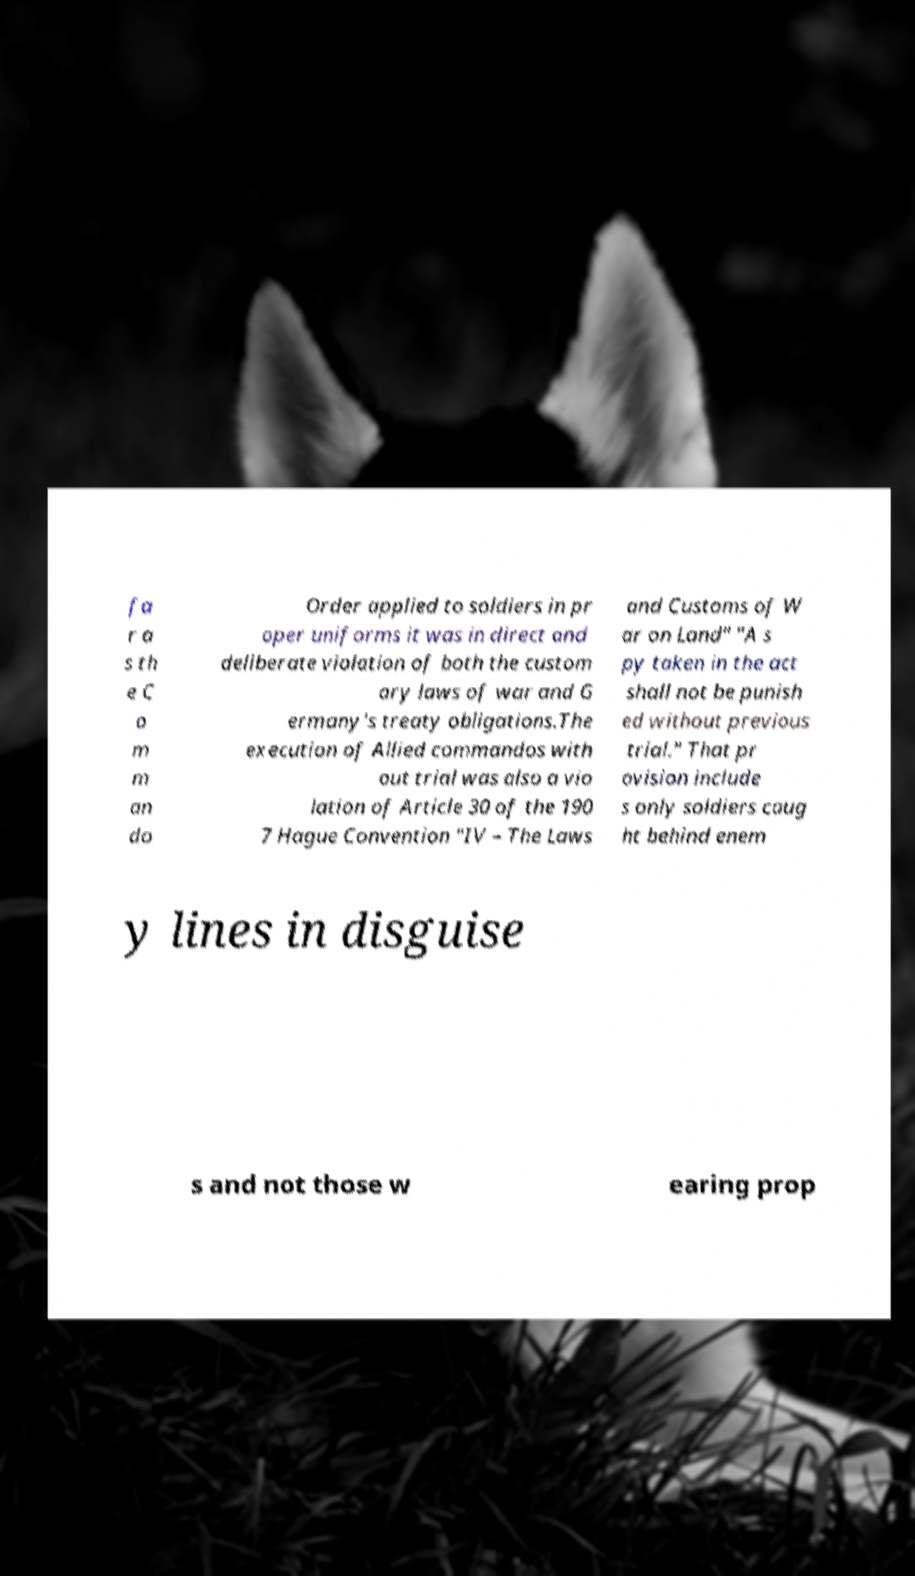For documentation purposes, I need the text within this image transcribed. Could you provide that? fa r a s th e C o m m an do Order applied to soldiers in pr oper uniforms it was in direct and deliberate violation of both the custom ary laws of war and G ermany's treaty obligations.The execution of Allied commandos with out trial was also a vio lation of Article 30 of the 190 7 Hague Convention "IV – The Laws and Customs of W ar on Land" "A s py taken in the act shall not be punish ed without previous trial." That pr ovision include s only soldiers caug ht behind enem y lines in disguise s and not those w earing prop 